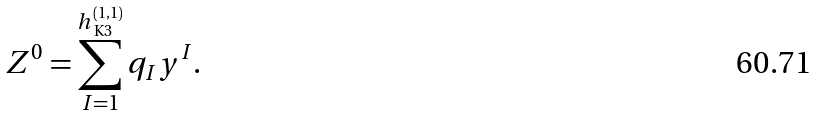Convert formula to latex. <formula><loc_0><loc_0><loc_500><loc_500>Z ^ { 0 } = \sum _ { I = 1 } ^ { h _ { \text { K3} } ^ { \left ( 1 , 1 \right ) } } q _ { I } y ^ { I } .</formula> 